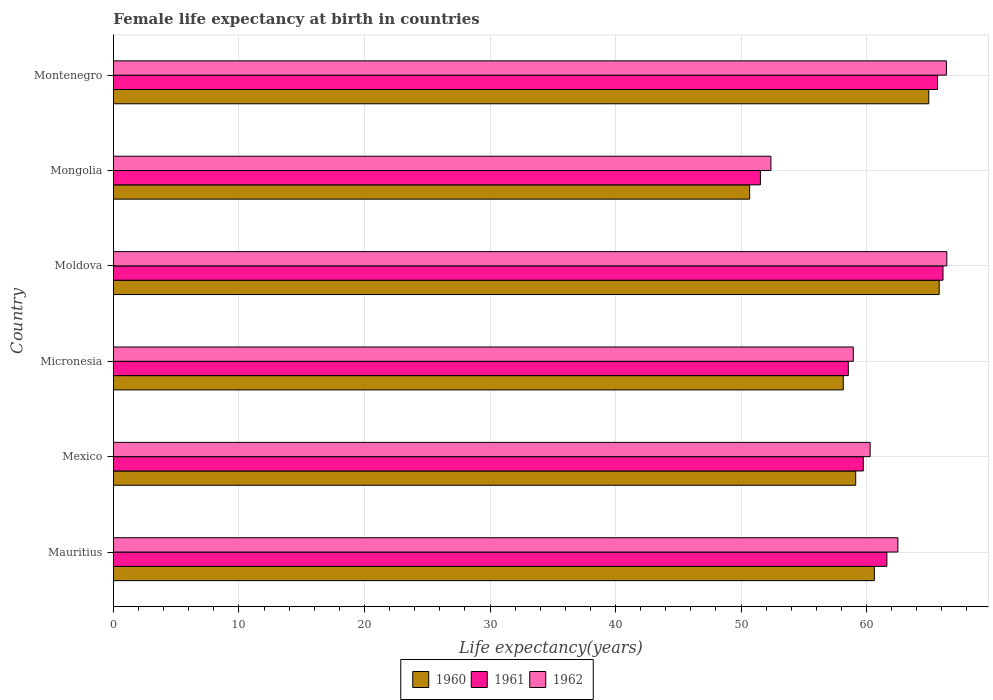How many groups of bars are there?
Keep it short and to the point. 6. How many bars are there on the 5th tick from the bottom?
Keep it short and to the point. 3. What is the label of the 1st group of bars from the top?
Provide a succinct answer. Montenegro. What is the female life expectancy at birth in 1961 in Micronesia?
Your answer should be compact. 58.55. Across all countries, what is the maximum female life expectancy at birth in 1960?
Your answer should be compact. 65.79. Across all countries, what is the minimum female life expectancy at birth in 1960?
Give a very brief answer. 50.69. In which country was the female life expectancy at birth in 1962 maximum?
Offer a terse response. Moldova. In which country was the female life expectancy at birth in 1961 minimum?
Offer a very short reply. Mongolia. What is the total female life expectancy at birth in 1962 in the graph?
Provide a succinct answer. 366.89. What is the difference between the female life expectancy at birth in 1961 in Mauritius and that in Moldova?
Offer a very short reply. -4.47. What is the difference between the female life expectancy at birth in 1960 in Mongolia and the female life expectancy at birth in 1962 in Micronesia?
Your answer should be compact. -8.26. What is the average female life expectancy at birth in 1962 per country?
Make the answer very short. 61.15. What is the difference between the female life expectancy at birth in 1962 and female life expectancy at birth in 1960 in Mexico?
Your answer should be compact. 1.15. In how many countries, is the female life expectancy at birth in 1962 greater than 8 years?
Provide a short and direct response. 6. What is the ratio of the female life expectancy at birth in 1961 in Micronesia to that in Moldova?
Your answer should be very brief. 0.89. Is the difference between the female life expectancy at birth in 1962 in Micronesia and Mongolia greater than the difference between the female life expectancy at birth in 1960 in Micronesia and Mongolia?
Provide a short and direct response. No. What is the difference between the highest and the second highest female life expectancy at birth in 1960?
Provide a succinct answer. 0.83. What is the difference between the highest and the lowest female life expectancy at birth in 1960?
Provide a short and direct response. 15.1. In how many countries, is the female life expectancy at birth in 1960 greater than the average female life expectancy at birth in 1960 taken over all countries?
Your answer should be very brief. 3. Is the sum of the female life expectancy at birth in 1961 in Mexico and Moldova greater than the maximum female life expectancy at birth in 1962 across all countries?
Your response must be concise. Yes. What does the 3rd bar from the top in Micronesia represents?
Your answer should be very brief. 1960. What does the 2nd bar from the bottom in Micronesia represents?
Keep it short and to the point. 1961. Is it the case that in every country, the sum of the female life expectancy at birth in 1961 and female life expectancy at birth in 1962 is greater than the female life expectancy at birth in 1960?
Offer a terse response. Yes. How many bars are there?
Offer a very short reply. 18. Are all the bars in the graph horizontal?
Your answer should be compact. Yes. Are the values on the major ticks of X-axis written in scientific E-notation?
Provide a short and direct response. No. Does the graph contain any zero values?
Provide a succinct answer. No. Where does the legend appear in the graph?
Ensure brevity in your answer.  Bottom center. How are the legend labels stacked?
Provide a short and direct response. Horizontal. What is the title of the graph?
Offer a very short reply. Female life expectancy at birth in countries. What is the label or title of the X-axis?
Keep it short and to the point. Life expectancy(years). What is the Life expectancy(years) of 1960 in Mauritius?
Provide a succinct answer. 60.63. What is the Life expectancy(years) of 1961 in Mauritius?
Your answer should be compact. 61.62. What is the Life expectancy(years) of 1962 in Mauritius?
Provide a short and direct response. 62.5. What is the Life expectancy(years) in 1960 in Mexico?
Provide a succinct answer. 59.14. What is the Life expectancy(years) in 1961 in Mexico?
Your response must be concise. 59.75. What is the Life expectancy(years) in 1962 in Mexico?
Ensure brevity in your answer.  60.29. What is the Life expectancy(years) of 1960 in Micronesia?
Your answer should be very brief. 58.15. What is the Life expectancy(years) in 1961 in Micronesia?
Offer a terse response. 58.55. What is the Life expectancy(years) in 1962 in Micronesia?
Your answer should be very brief. 58.95. What is the Life expectancy(years) in 1960 in Moldova?
Provide a succinct answer. 65.79. What is the Life expectancy(years) in 1961 in Moldova?
Give a very brief answer. 66.1. What is the Life expectancy(years) of 1962 in Moldova?
Provide a short and direct response. 66.4. What is the Life expectancy(years) in 1960 in Mongolia?
Provide a short and direct response. 50.69. What is the Life expectancy(years) of 1961 in Mongolia?
Provide a succinct answer. 51.55. What is the Life expectancy(years) in 1962 in Mongolia?
Offer a terse response. 52.38. What is the Life expectancy(years) of 1960 in Montenegro?
Give a very brief answer. 64.96. What is the Life expectancy(years) in 1961 in Montenegro?
Your answer should be very brief. 65.66. What is the Life expectancy(years) in 1962 in Montenegro?
Your answer should be very brief. 66.37. Across all countries, what is the maximum Life expectancy(years) in 1960?
Offer a terse response. 65.79. Across all countries, what is the maximum Life expectancy(years) in 1961?
Your response must be concise. 66.1. Across all countries, what is the maximum Life expectancy(years) of 1962?
Ensure brevity in your answer.  66.4. Across all countries, what is the minimum Life expectancy(years) in 1960?
Your response must be concise. 50.69. Across all countries, what is the minimum Life expectancy(years) of 1961?
Keep it short and to the point. 51.55. Across all countries, what is the minimum Life expectancy(years) in 1962?
Ensure brevity in your answer.  52.38. What is the total Life expectancy(years) in 1960 in the graph?
Provide a short and direct response. 359.35. What is the total Life expectancy(years) in 1961 in the graph?
Your answer should be very brief. 363.23. What is the total Life expectancy(years) in 1962 in the graph?
Provide a succinct answer. 366.89. What is the difference between the Life expectancy(years) in 1960 in Mauritius and that in Mexico?
Provide a short and direct response. 1.49. What is the difference between the Life expectancy(years) in 1961 in Mauritius and that in Mexico?
Offer a terse response. 1.87. What is the difference between the Life expectancy(years) in 1962 in Mauritius and that in Mexico?
Your response must be concise. 2.21. What is the difference between the Life expectancy(years) in 1960 in Mauritius and that in Micronesia?
Keep it short and to the point. 2.48. What is the difference between the Life expectancy(years) of 1961 in Mauritius and that in Micronesia?
Offer a terse response. 3.07. What is the difference between the Life expectancy(years) in 1962 in Mauritius and that in Micronesia?
Ensure brevity in your answer.  3.55. What is the difference between the Life expectancy(years) in 1960 in Mauritius and that in Moldova?
Ensure brevity in your answer.  -5.17. What is the difference between the Life expectancy(years) of 1961 in Mauritius and that in Moldova?
Make the answer very short. -4.47. What is the difference between the Life expectancy(years) of 1960 in Mauritius and that in Mongolia?
Provide a short and direct response. 9.94. What is the difference between the Life expectancy(years) in 1961 in Mauritius and that in Mongolia?
Your answer should be compact. 10.07. What is the difference between the Life expectancy(years) of 1962 in Mauritius and that in Mongolia?
Keep it short and to the point. 10.12. What is the difference between the Life expectancy(years) of 1960 in Mauritius and that in Montenegro?
Offer a terse response. -4.33. What is the difference between the Life expectancy(years) in 1961 in Mauritius and that in Montenegro?
Provide a succinct answer. -4.04. What is the difference between the Life expectancy(years) in 1962 in Mauritius and that in Montenegro?
Your response must be concise. -3.87. What is the difference between the Life expectancy(years) of 1960 in Mexico and that in Micronesia?
Keep it short and to the point. 0.99. What is the difference between the Life expectancy(years) of 1961 in Mexico and that in Micronesia?
Offer a terse response. 1.2. What is the difference between the Life expectancy(years) of 1962 in Mexico and that in Micronesia?
Provide a short and direct response. 1.34. What is the difference between the Life expectancy(years) of 1960 in Mexico and that in Moldova?
Provide a succinct answer. -6.65. What is the difference between the Life expectancy(years) in 1961 in Mexico and that in Moldova?
Give a very brief answer. -6.35. What is the difference between the Life expectancy(years) of 1962 in Mexico and that in Moldova?
Your answer should be compact. -6.11. What is the difference between the Life expectancy(years) in 1960 in Mexico and that in Mongolia?
Make the answer very short. 8.45. What is the difference between the Life expectancy(years) of 1961 in Mexico and that in Mongolia?
Give a very brief answer. 8.2. What is the difference between the Life expectancy(years) in 1962 in Mexico and that in Mongolia?
Your response must be concise. 7.91. What is the difference between the Life expectancy(years) of 1960 in Mexico and that in Montenegro?
Keep it short and to the point. -5.82. What is the difference between the Life expectancy(years) in 1961 in Mexico and that in Montenegro?
Make the answer very short. -5.91. What is the difference between the Life expectancy(years) in 1962 in Mexico and that in Montenegro?
Provide a short and direct response. -6.08. What is the difference between the Life expectancy(years) in 1960 in Micronesia and that in Moldova?
Your answer should be very brief. -7.64. What is the difference between the Life expectancy(years) of 1961 in Micronesia and that in Moldova?
Your answer should be compact. -7.55. What is the difference between the Life expectancy(years) of 1962 in Micronesia and that in Moldova?
Offer a very short reply. -7.45. What is the difference between the Life expectancy(years) of 1960 in Micronesia and that in Mongolia?
Offer a very short reply. 7.46. What is the difference between the Life expectancy(years) in 1961 in Micronesia and that in Mongolia?
Make the answer very short. 7. What is the difference between the Life expectancy(years) of 1962 in Micronesia and that in Mongolia?
Your response must be concise. 6.56. What is the difference between the Life expectancy(years) in 1960 in Micronesia and that in Montenegro?
Ensure brevity in your answer.  -6.81. What is the difference between the Life expectancy(years) of 1961 in Micronesia and that in Montenegro?
Your answer should be compact. -7.11. What is the difference between the Life expectancy(years) of 1962 in Micronesia and that in Montenegro?
Offer a terse response. -7.42. What is the difference between the Life expectancy(years) of 1960 in Moldova and that in Mongolia?
Your response must be concise. 15.1. What is the difference between the Life expectancy(years) in 1961 in Moldova and that in Mongolia?
Provide a short and direct response. 14.55. What is the difference between the Life expectancy(years) in 1962 in Moldova and that in Mongolia?
Provide a succinct answer. 14.02. What is the difference between the Life expectancy(years) of 1960 in Moldova and that in Montenegro?
Your response must be concise. 0.83. What is the difference between the Life expectancy(years) in 1961 in Moldova and that in Montenegro?
Ensure brevity in your answer.  0.43. What is the difference between the Life expectancy(years) of 1962 in Moldova and that in Montenegro?
Make the answer very short. 0.03. What is the difference between the Life expectancy(years) in 1960 in Mongolia and that in Montenegro?
Your response must be concise. -14.27. What is the difference between the Life expectancy(years) of 1961 in Mongolia and that in Montenegro?
Make the answer very short. -14.11. What is the difference between the Life expectancy(years) in 1962 in Mongolia and that in Montenegro?
Provide a short and direct response. -13.98. What is the difference between the Life expectancy(years) in 1960 in Mauritius and the Life expectancy(years) in 1961 in Mexico?
Your response must be concise. 0.88. What is the difference between the Life expectancy(years) of 1960 in Mauritius and the Life expectancy(years) of 1962 in Mexico?
Give a very brief answer. 0.34. What is the difference between the Life expectancy(years) of 1961 in Mauritius and the Life expectancy(years) of 1962 in Mexico?
Provide a short and direct response. 1.33. What is the difference between the Life expectancy(years) of 1960 in Mauritius and the Life expectancy(years) of 1961 in Micronesia?
Your answer should be compact. 2.08. What is the difference between the Life expectancy(years) in 1960 in Mauritius and the Life expectancy(years) in 1962 in Micronesia?
Offer a terse response. 1.68. What is the difference between the Life expectancy(years) in 1961 in Mauritius and the Life expectancy(years) in 1962 in Micronesia?
Offer a terse response. 2.68. What is the difference between the Life expectancy(years) in 1960 in Mauritius and the Life expectancy(years) in 1961 in Moldova?
Offer a terse response. -5.47. What is the difference between the Life expectancy(years) of 1960 in Mauritius and the Life expectancy(years) of 1962 in Moldova?
Provide a succinct answer. -5.77. What is the difference between the Life expectancy(years) of 1961 in Mauritius and the Life expectancy(years) of 1962 in Moldova?
Provide a short and direct response. -4.78. What is the difference between the Life expectancy(years) of 1960 in Mauritius and the Life expectancy(years) of 1961 in Mongolia?
Ensure brevity in your answer.  9.08. What is the difference between the Life expectancy(years) of 1960 in Mauritius and the Life expectancy(years) of 1962 in Mongolia?
Provide a succinct answer. 8.24. What is the difference between the Life expectancy(years) in 1961 in Mauritius and the Life expectancy(years) in 1962 in Mongolia?
Ensure brevity in your answer.  9.24. What is the difference between the Life expectancy(years) of 1960 in Mauritius and the Life expectancy(years) of 1961 in Montenegro?
Provide a short and direct response. -5.04. What is the difference between the Life expectancy(years) in 1960 in Mauritius and the Life expectancy(years) in 1962 in Montenegro?
Ensure brevity in your answer.  -5.74. What is the difference between the Life expectancy(years) of 1961 in Mauritius and the Life expectancy(years) of 1962 in Montenegro?
Provide a short and direct response. -4.75. What is the difference between the Life expectancy(years) of 1960 in Mexico and the Life expectancy(years) of 1961 in Micronesia?
Provide a succinct answer. 0.59. What is the difference between the Life expectancy(years) in 1960 in Mexico and the Life expectancy(years) in 1962 in Micronesia?
Make the answer very short. 0.19. What is the difference between the Life expectancy(years) in 1961 in Mexico and the Life expectancy(years) in 1962 in Micronesia?
Your response must be concise. 0.8. What is the difference between the Life expectancy(years) of 1960 in Mexico and the Life expectancy(years) of 1961 in Moldova?
Give a very brief answer. -6.96. What is the difference between the Life expectancy(years) of 1960 in Mexico and the Life expectancy(years) of 1962 in Moldova?
Keep it short and to the point. -7.26. What is the difference between the Life expectancy(years) in 1961 in Mexico and the Life expectancy(years) in 1962 in Moldova?
Ensure brevity in your answer.  -6.65. What is the difference between the Life expectancy(years) of 1960 in Mexico and the Life expectancy(years) of 1961 in Mongolia?
Provide a succinct answer. 7.59. What is the difference between the Life expectancy(years) in 1960 in Mexico and the Life expectancy(years) in 1962 in Mongolia?
Provide a succinct answer. 6.75. What is the difference between the Life expectancy(years) in 1961 in Mexico and the Life expectancy(years) in 1962 in Mongolia?
Make the answer very short. 7.37. What is the difference between the Life expectancy(years) of 1960 in Mexico and the Life expectancy(years) of 1961 in Montenegro?
Your answer should be compact. -6.52. What is the difference between the Life expectancy(years) of 1960 in Mexico and the Life expectancy(years) of 1962 in Montenegro?
Your answer should be very brief. -7.23. What is the difference between the Life expectancy(years) in 1961 in Mexico and the Life expectancy(years) in 1962 in Montenegro?
Offer a very short reply. -6.62. What is the difference between the Life expectancy(years) in 1960 in Micronesia and the Life expectancy(years) in 1961 in Moldova?
Give a very brief answer. -7.95. What is the difference between the Life expectancy(years) in 1960 in Micronesia and the Life expectancy(years) in 1962 in Moldova?
Offer a terse response. -8.25. What is the difference between the Life expectancy(years) of 1961 in Micronesia and the Life expectancy(years) of 1962 in Moldova?
Your answer should be compact. -7.85. What is the difference between the Life expectancy(years) in 1960 in Micronesia and the Life expectancy(years) in 1961 in Mongolia?
Your response must be concise. 6.6. What is the difference between the Life expectancy(years) in 1960 in Micronesia and the Life expectancy(years) in 1962 in Mongolia?
Your answer should be compact. 5.77. What is the difference between the Life expectancy(years) of 1961 in Micronesia and the Life expectancy(years) of 1962 in Mongolia?
Your answer should be compact. 6.17. What is the difference between the Life expectancy(years) of 1960 in Micronesia and the Life expectancy(years) of 1961 in Montenegro?
Offer a terse response. -7.51. What is the difference between the Life expectancy(years) in 1960 in Micronesia and the Life expectancy(years) in 1962 in Montenegro?
Offer a terse response. -8.22. What is the difference between the Life expectancy(years) in 1961 in Micronesia and the Life expectancy(years) in 1962 in Montenegro?
Your answer should be very brief. -7.82. What is the difference between the Life expectancy(years) of 1960 in Moldova and the Life expectancy(years) of 1961 in Mongolia?
Provide a short and direct response. 14.24. What is the difference between the Life expectancy(years) in 1960 in Moldova and the Life expectancy(years) in 1962 in Mongolia?
Provide a succinct answer. 13.41. What is the difference between the Life expectancy(years) in 1961 in Moldova and the Life expectancy(years) in 1962 in Mongolia?
Your answer should be compact. 13.71. What is the difference between the Life expectancy(years) of 1960 in Moldova and the Life expectancy(years) of 1961 in Montenegro?
Provide a succinct answer. 0.13. What is the difference between the Life expectancy(years) of 1960 in Moldova and the Life expectancy(years) of 1962 in Montenegro?
Your answer should be compact. -0.58. What is the difference between the Life expectancy(years) in 1961 in Moldova and the Life expectancy(years) in 1962 in Montenegro?
Ensure brevity in your answer.  -0.27. What is the difference between the Life expectancy(years) in 1960 in Mongolia and the Life expectancy(years) in 1961 in Montenegro?
Your answer should be compact. -14.97. What is the difference between the Life expectancy(years) of 1960 in Mongolia and the Life expectancy(years) of 1962 in Montenegro?
Keep it short and to the point. -15.68. What is the difference between the Life expectancy(years) in 1961 in Mongolia and the Life expectancy(years) in 1962 in Montenegro?
Make the answer very short. -14.82. What is the average Life expectancy(years) in 1960 per country?
Your response must be concise. 59.89. What is the average Life expectancy(years) of 1961 per country?
Offer a terse response. 60.54. What is the average Life expectancy(years) of 1962 per country?
Give a very brief answer. 61.15. What is the difference between the Life expectancy(years) in 1960 and Life expectancy(years) in 1961 in Mauritius?
Your response must be concise. -1. What is the difference between the Life expectancy(years) of 1960 and Life expectancy(years) of 1962 in Mauritius?
Offer a very short reply. -1.87. What is the difference between the Life expectancy(years) in 1961 and Life expectancy(years) in 1962 in Mauritius?
Provide a succinct answer. -0.88. What is the difference between the Life expectancy(years) in 1960 and Life expectancy(years) in 1961 in Mexico?
Your answer should be very brief. -0.61. What is the difference between the Life expectancy(years) in 1960 and Life expectancy(years) in 1962 in Mexico?
Your answer should be very brief. -1.15. What is the difference between the Life expectancy(years) in 1961 and Life expectancy(years) in 1962 in Mexico?
Offer a very short reply. -0.54. What is the difference between the Life expectancy(years) in 1960 and Life expectancy(years) in 1961 in Micronesia?
Provide a short and direct response. -0.4. What is the difference between the Life expectancy(years) in 1960 and Life expectancy(years) in 1962 in Micronesia?
Ensure brevity in your answer.  -0.8. What is the difference between the Life expectancy(years) of 1961 and Life expectancy(years) of 1962 in Micronesia?
Keep it short and to the point. -0.4. What is the difference between the Life expectancy(years) of 1960 and Life expectancy(years) of 1961 in Moldova?
Ensure brevity in your answer.  -0.3. What is the difference between the Life expectancy(years) in 1960 and Life expectancy(years) in 1962 in Moldova?
Keep it short and to the point. -0.61. What is the difference between the Life expectancy(years) of 1961 and Life expectancy(years) of 1962 in Moldova?
Your answer should be compact. -0.3. What is the difference between the Life expectancy(years) of 1960 and Life expectancy(years) of 1961 in Mongolia?
Your answer should be compact. -0.86. What is the difference between the Life expectancy(years) in 1960 and Life expectancy(years) in 1962 in Mongolia?
Keep it short and to the point. -1.7. What is the difference between the Life expectancy(years) in 1961 and Life expectancy(years) in 1962 in Mongolia?
Give a very brief answer. -0.84. What is the difference between the Life expectancy(years) of 1960 and Life expectancy(years) of 1962 in Montenegro?
Provide a short and direct response. -1.41. What is the difference between the Life expectancy(years) in 1961 and Life expectancy(years) in 1962 in Montenegro?
Make the answer very short. -0.71. What is the ratio of the Life expectancy(years) of 1960 in Mauritius to that in Mexico?
Ensure brevity in your answer.  1.03. What is the ratio of the Life expectancy(years) in 1961 in Mauritius to that in Mexico?
Make the answer very short. 1.03. What is the ratio of the Life expectancy(years) of 1962 in Mauritius to that in Mexico?
Provide a succinct answer. 1.04. What is the ratio of the Life expectancy(years) in 1960 in Mauritius to that in Micronesia?
Give a very brief answer. 1.04. What is the ratio of the Life expectancy(years) of 1961 in Mauritius to that in Micronesia?
Provide a short and direct response. 1.05. What is the ratio of the Life expectancy(years) in 1962 in Mauritius to that in Micronesia?
Ensure brevity in your answer.  1.06. What is the ratio of the Life expectancy(years) in 1960 in Mauritius to that in Moldova?
Provide a succinct answer. 0.92. What is the ratio of the Life expectancy(years) in 1961 in Mauritius to that in Moldova?
Your answer should be compact. 0.93. What is the ratio of the Life expectancy(years) in 1962 in Mauritius to that in Moldova?
Keep it short and to the point. 0.94. What is the ratio of the Life expectancy(years) in 1960 in Mauritius to that in Mongolia?
Provide a short and direct response. 1.2. What is the ratio of the Life expectancy(years) of 1961 in Mauritius to that in Mongolia?
Your answer should be compact. 1.2. What is the ratio of the Life expectancy(years) of 1962 in Mauritius to that in Mongolia?
Offer a terse response. 1.19. What is the ratio of the Life expectancy(years) in 1961 in Mauritius to that in Montenegro?
Your answer should be very brief. 0.94. What is the ratio of the Life expectancy(years) of 1962 in Mauritius to that in Montenegro?
Your response must be concise. 0.94. What is the ratio of the Life expectancy(years) in 1960 in Mexico to that in Micronesia?
Keep it short and to the point. 1.02. What is the ratio of the Life expectancy(years) in 1961 in Mexico to that in Micronesia?
Make the answer very short. 1.02. What is the ratio of the Life expectancy(years) of 1962 in Mexico to that in Micronesia?
Your answer should be compact. 1.02. What is the ratio of the Life expectancy(years) in 1960 in Mexico to that in Moldova?
Offer a terse response. 0.9. What is the ratio of the Life expectancy(years) of 1961 in Mexico to that in Moldova?
Your answer should be very brief. 0.9. What is the ratio of the Life expectancy(years) in 1962 in Mexico to that in Moldova?
Provide a succinct answer. 0.91. What is the ratio of the Life expectancy(years) in 1961 in Mexico to that in Mongolia?
Make the answer very short. 1.16. What is the ratio of the Life expectancy(years) of 1962 in Mexico to that in Mongolia?
Provide a short and direct response. 1.15. What is the ratio of the Life expectancy(years) of 1960 in Mexico to that in Montenegro?
Offer a terse response. 0.91. What is the ratio of the Life expectancy(years) in 1961 in Mexico to that in Montenegro?
Ensure brevity in your answer.  0.91. What is the ratio of the Life expectancy(years) in 1962 in Mexico to that in Montenegro?
Your answer should be compact. 0.91. What is the ratio of the Life expectancy(years) in 1960 in Micronesia to that in Moldova?
Your answer should be very brief. 0.88. What is the ratio of the Life expectancy(years) in 1961 in Micronesia to that in Moldova?
Ensure brevity in your answer.  0.89. What is the ratio of the Life expectancy(years) in 1962 in Micronesia to that in Moldova?
Your response must be concise. 0.89. What is the ratio of the Life expectancy(years) of 1960 in Micronesia to that in Mongolia?
Your response must be concise. 1.15. What is the ratio of the Life expectancy(years) in 1961 in Micronesia to that in Mongolia?
Provide a succinct answer. 1.14. What is the ratio of the Life expectancy(years) of 1962 in Micronesia to that in Mongolia?
Your answer should be compact. 1.13. What is the ratio of the Life expectancy(years) in 1960 in Micronesia to that in Montenegro?
Give a very brief answer. 0.9. What is the ratio of the Life expectancy(years) of 1961 in Micronesia to that in Montenegro?
Your response must be concise. 0.89. What is the ratio of the Life expectancy(years) in 1962 in Micronesia to that in Montenegro?
Make the answer very short. 0.89. What is the ratio of the Life expectancy(years) in 1960 in Moldova to that in Mongolia?
Provide a short and direct response. 1.3. What is the ratio of the Life expectancy(years) of 1961 in Moldova to that in Mongolia?
Keep it short and to the point. 1.28. What is the ratio of the Life expectancy(years) in 1962 in Moldova to that in Mongolia?
Give a very brief answer. 1.27. What is the ratio of the Life expectancy(years) in 1960 in Moldova to that in Montenegro?
Offer a terse response. 1.01. What is the ratio of the Life expectancy(years) of 1961 in Moldova to that in Montenegro?
Your answer should be very brief. 1.01. What is the ratio of the Life expectancy(years) in 1960 in Mongolia to that in Montenegro?
Make the answer very short. 0.78. What is the ratio of the Life expectancy(years) of 1961 in Mongolia to that in Montenegro?
Provide a short and direct response. 0.79. What is the ratio of the Life expectancy(years) of 1962 in Mongolia to that in Montenegro?
Ensure brevity in your answer.  0.79. What is the difference between the highest and the second highest Life expectancy(years) in 1960?
Your answer should be very brief. 0.83. What is the difference between the highest and the second highest Life expectancy(years) in 1961?
Your answer should be very brief. 0.43. What is the difference between the highest and the second highest Life expectancy(years) in 1962?
Provide a succinct answer. 0.03. What is the difference between the highest and the lowest Life expectancy(years) of 1960?
Provide a succinct answer. 15.1. What is the difference between the highest and the lowest Life expectancy(years) in 1961?
Ensure brevity in your answer.  14.55. What is the difference between the highest and the lowest Life expectancy(years) in 1962?
Ensure brevity in your answer.  14.02. 